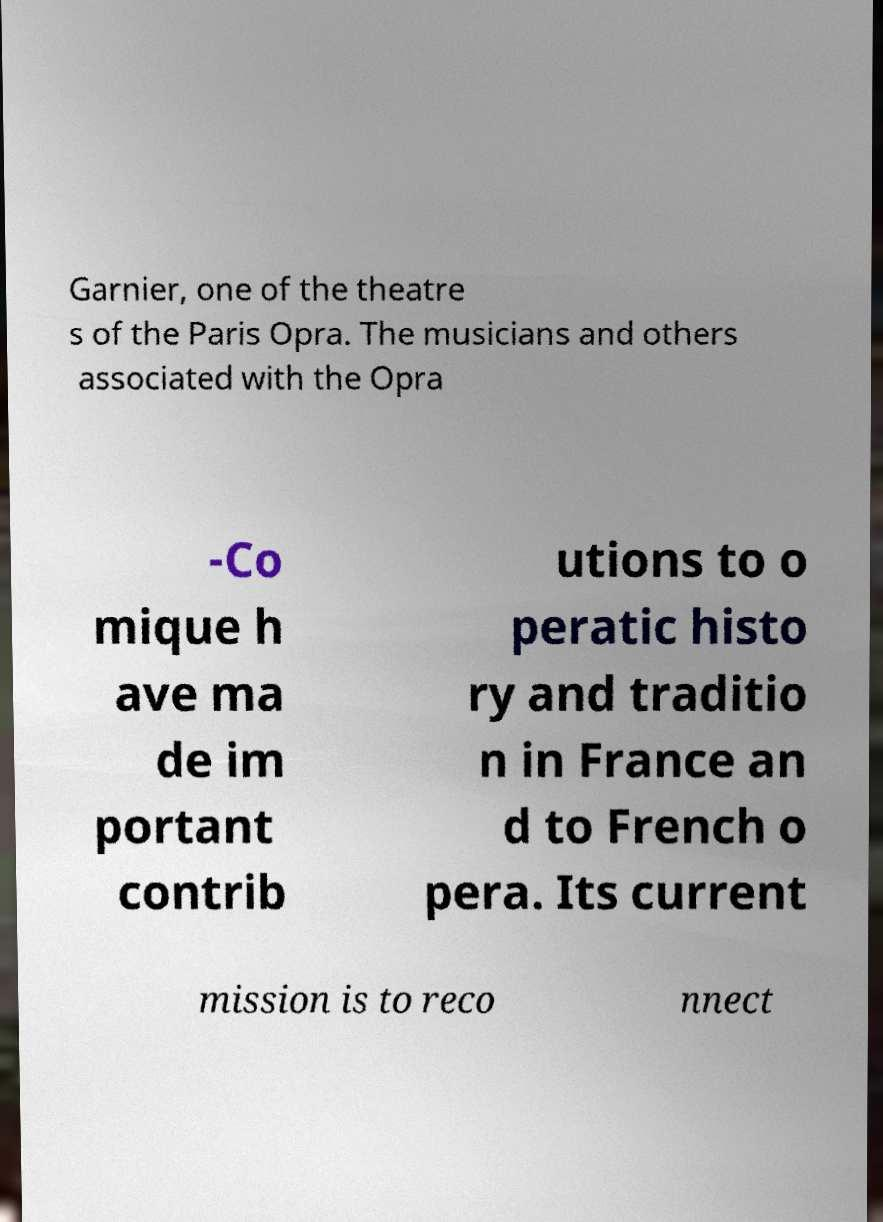Could you assist in decoding the text presented in this image and type it out clearly? Garnier, one of the theatre s of the Paris Opra. The musicians and others associated with the Opra -Co mique h ave ma de im portant contrib utions to o peratic histo ry and traditio n in France an d to French o pera. Its current mission is to reco nnect 